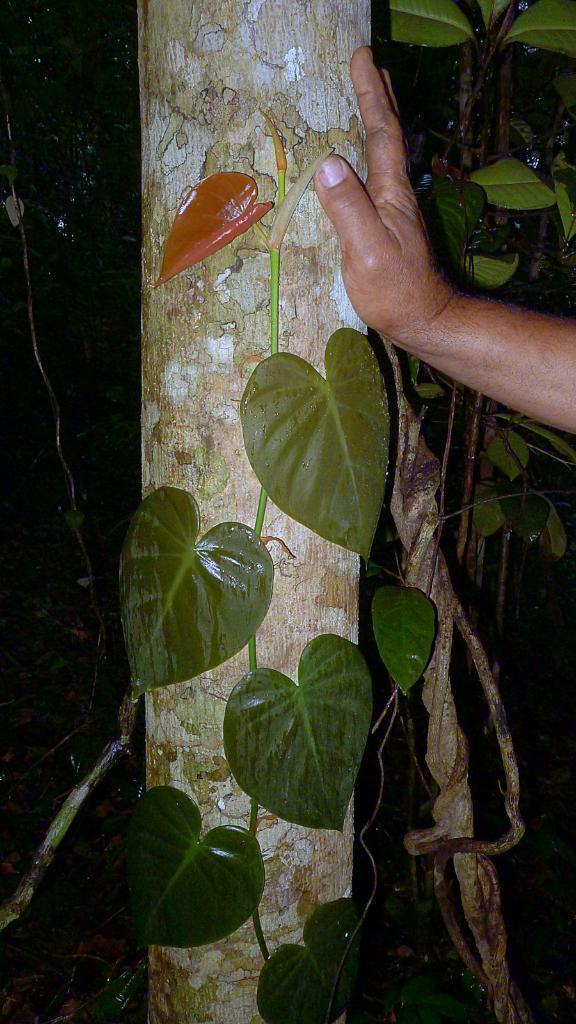Can you describe this image briefly? In this image I can see the truck and the person's hand on it. I can see few green color leaves and the black color background. 